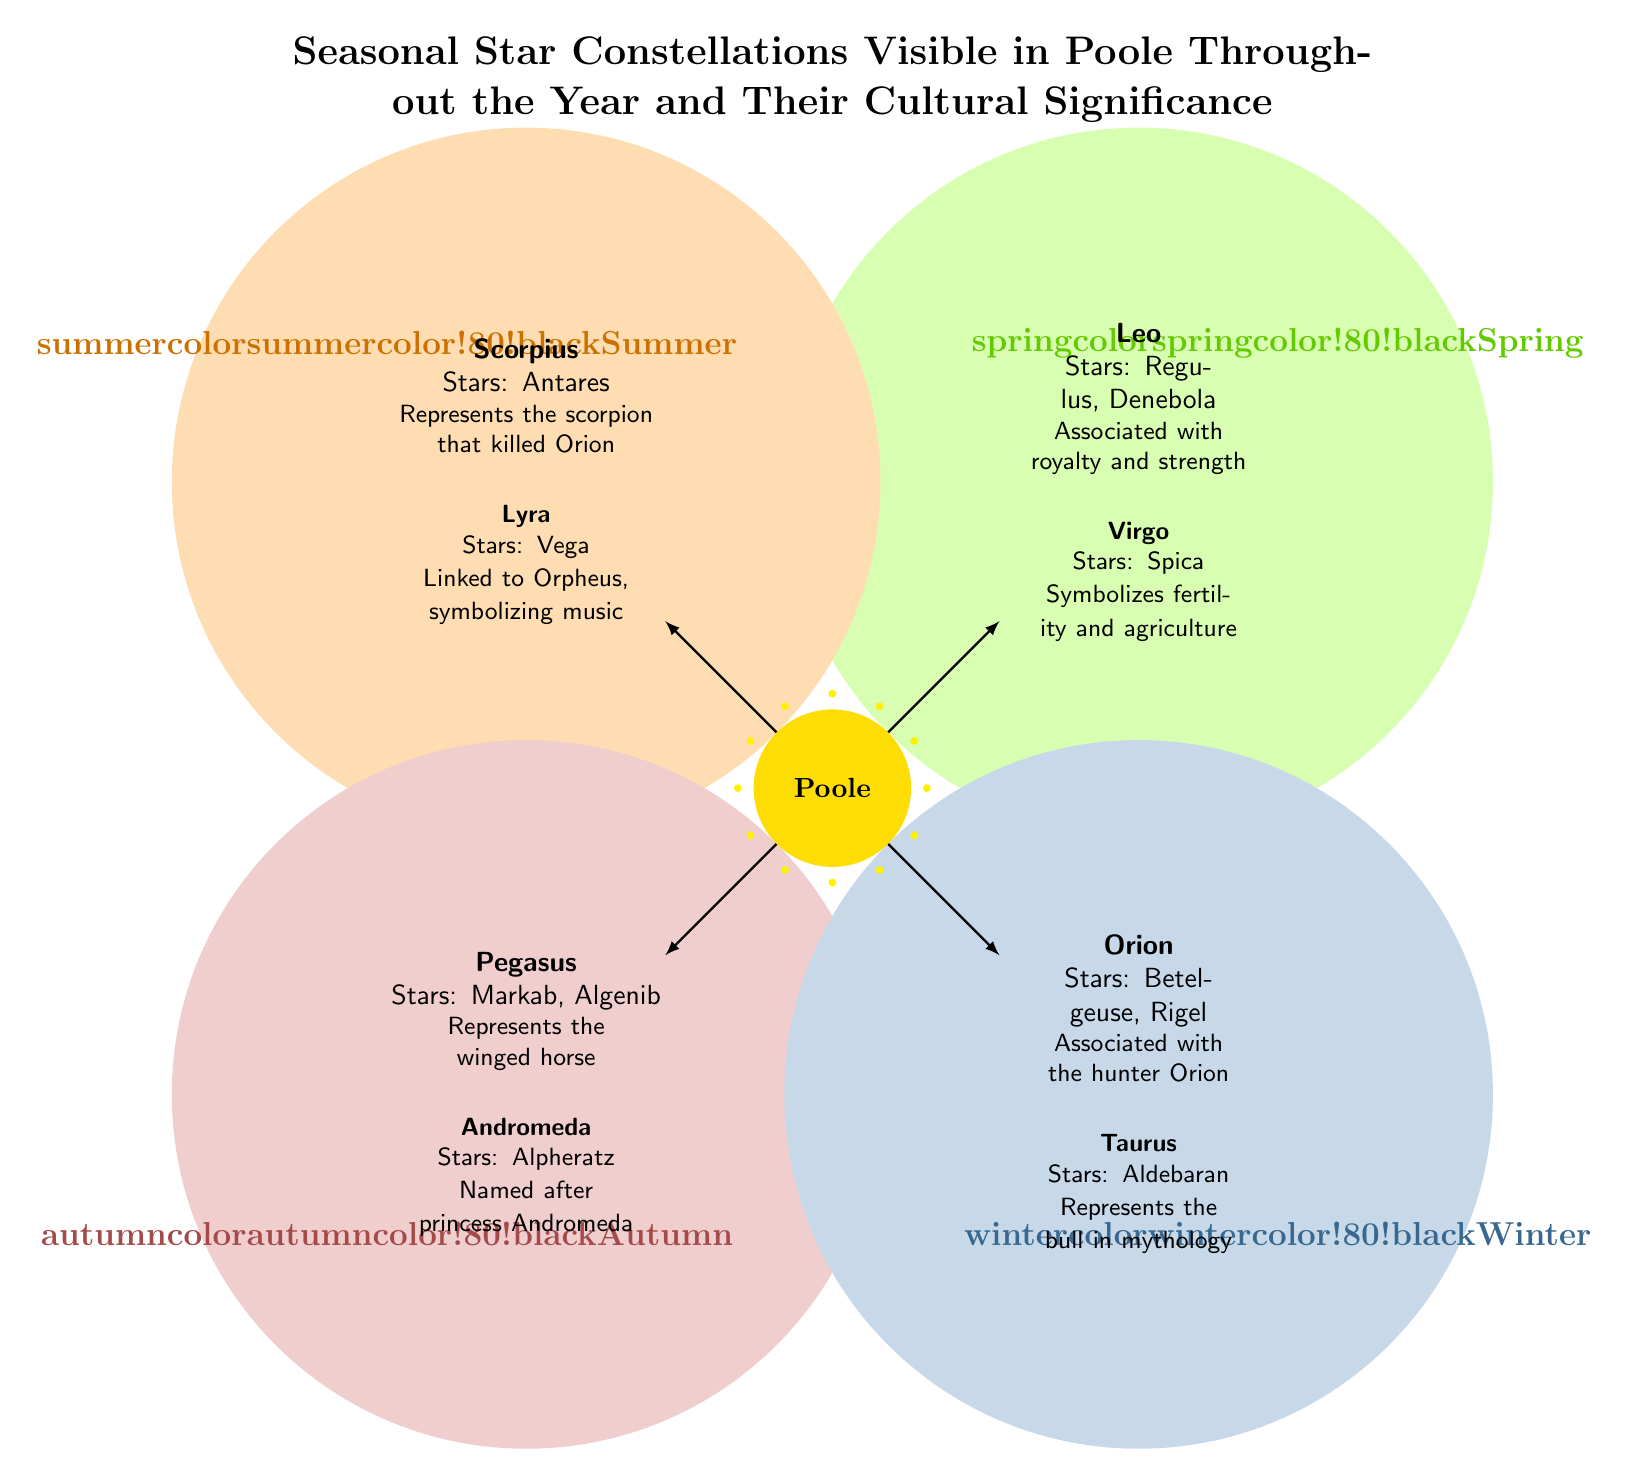What are the two constellations associated with spring? The diagram shows Leo and Virgo as the two constellations labeled in the spring section.
Answer: Leo and Virgo Which star is linked to Orpheus? In the summer section of the diagram, Lyra is noted as being linked to Orpheus; specifically, it mentions the star Vega.
Answer: Lyra What is the cultural significance of Taurus? Taurus is described in the winter section of the diagram as representing the bull in mythology, indicating its cultural symbolism.
Answer: Represents the bull in mythology How many constellations are shown for each season? The diagram indicates that there are two constellations listed for each of the four seasons: spring, summer, autumn, and winter. Thus, by counting them, we can determine that there are eight constellations in total.
Answer: 2 Which constellation represents a winged horse? In the autumn section of the diagram, Pegasus is specifically labeled as representing the winged horse.
Answer: Pegasus What does Virgo symbolize? Virgo is outlined in the spring section of the diagram and is noted for symbolizing fertility and agriculture.
Answer: Fertility and agriculture Which season includes the constellation Orion? The diagram clearly displays that Orion is featured in the winter section, as indicated by its location in the diagram.
Answer: Winter What star is associated with the scorpion? The diagram specifies that Antares, located in the constellation Scorpius, is associated with the scorpion that killed Orion.
Answer: Antares 